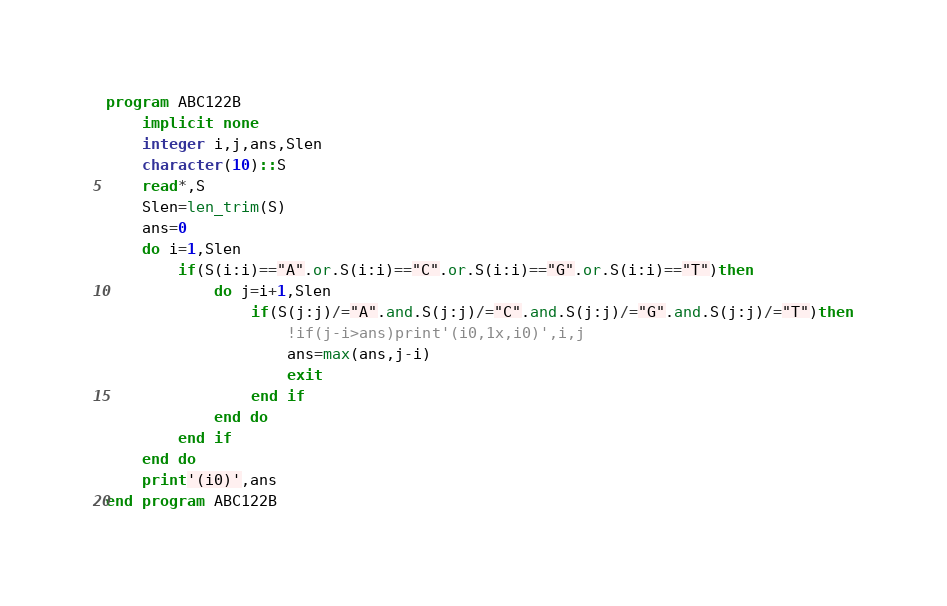<code> <loc_0><loc_0><loc_500><loc_500><_FORTRAN_>program ABC122B
    implicit none
    integer i,j,ans,Slen
    character(10)::S
    read*,S
    Slen=len_trim(S)
    ans=0
    do i=1,Slen
        if(S(i:i)=="A".or.S(i:i)=="C".or.S(i:i)=="G".or.S(i:i)=="T")then
            do j=i+1,Slen
                if(S(j:j)/="A".and.S(j:j)/="C".and.S(j:j)/="G".and.S(j:j)/="T")then
                    !if(j-i>ans)print'(i0,1x,i0)',i,j
                    ans=max(ans,j-i)
                    exit
                end if
            end do
        end if
    end do
    print'(i0)',ans
end program ABC122B</code> 